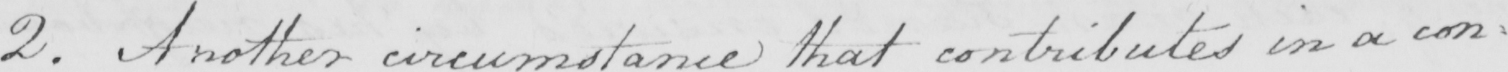What does this handwritten line say? 2 . Another circumstance that contributes in a con= 